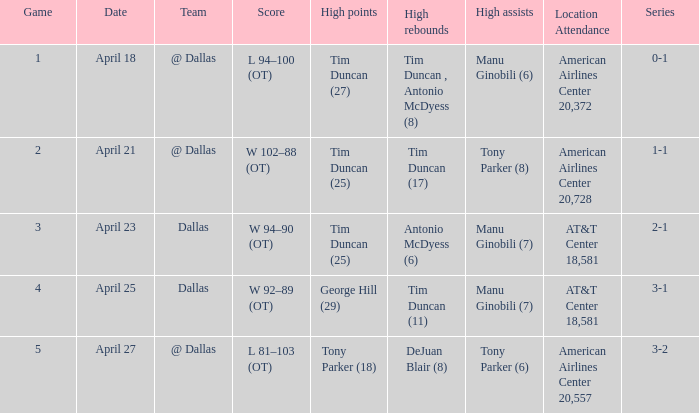When george hill (29) has the highest amount of points what is the date? April 25. Can you parse all the data within this table? {'header': ['Game', 'Date', 'Team', 'Score', 'High points', 'High rebounds', 'High assists', 'Location Attendance', 'Series'], 'rows': [['1', 'April 18', '@ Dallas', 'L 94–100 (OT)', 'Tim Duncan (27)', 'Tim Duncan , Antonio McDyess (8)', 'Manu Ginobili (6)', 'American Airlines Center 20,372', '0-1'], ['2', 'April 21', '@ Dallas', 'W 102–88 (OT)', 'Tim Duncan (25)', 'Tim Duncan (17)', 'Tony Parker (8)', 'American Airlines Center 20,728', '1-1'], ['3', 'April 23', 'Dallas', 'W 94–90 (OT)', 'Tim Duncan (25)', 'Antonio McDyess (6)', 'Manu Ginobili (7)', 'AT&T Center 18,581', '2-1'], ['4', 'April 25', 'Dallas', 'W 92–89 (OT)', 'George Hill (29)', 'Tim Duncan (11)', 'Manu Ginobili (7)', 'AT&T Center 18,581', '3-1'], ['5', 'April 27', '@ Dallas', 'L 81–103 (OT)', 'Tony Parker (18)', 'DeJuan Blair (8)', 'Tony Parker (6)', 'American Airlines Center 20,557', '3-2']]} 